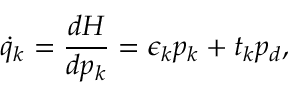Convert formula to latex. <formula><loc_0><loc_0><loc_500><loc_500>\dot { q } _ { k } = \frac { d H } { d p _ { k } } = \epsilon _ { k } p _ { k } + t _ { k } p _ { d } ,</formula> 